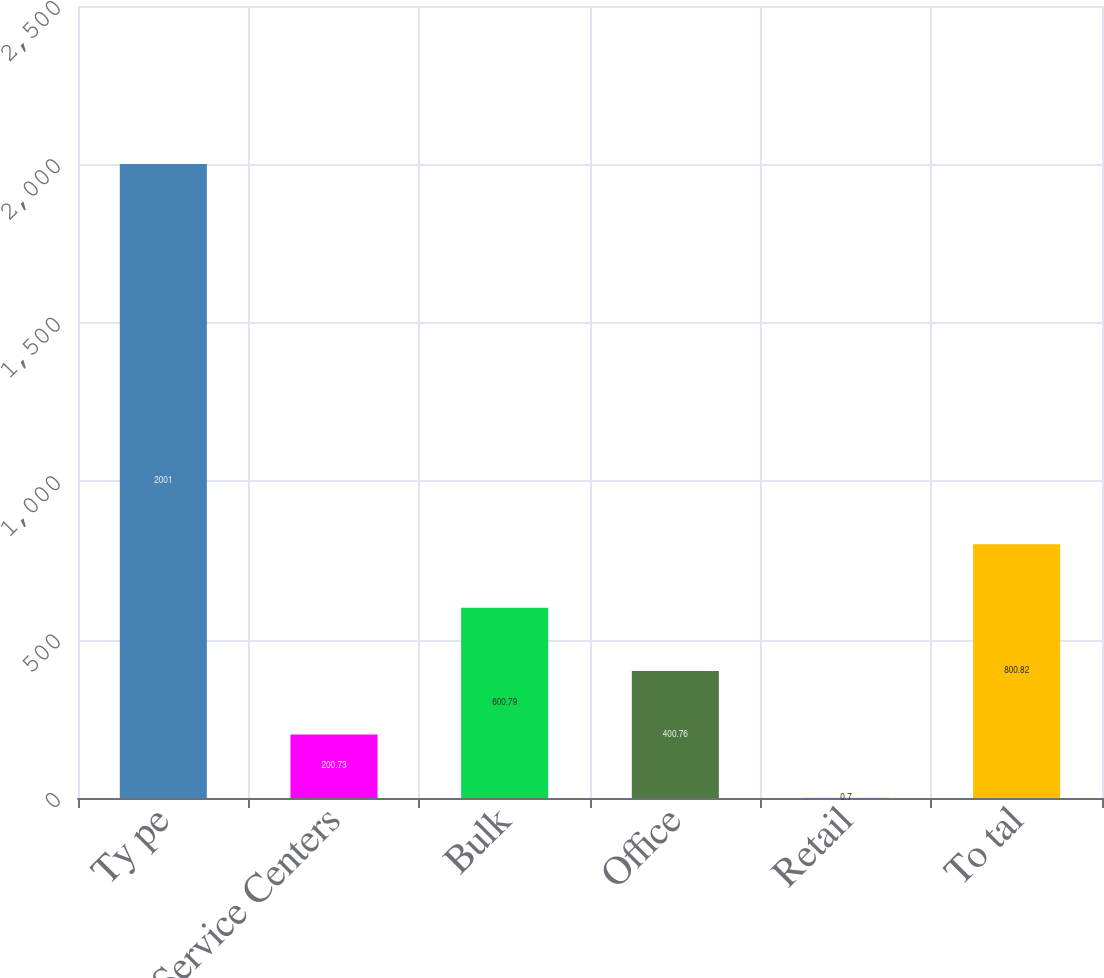<chart> <loc_0><loc_0><loc_500><loc_500><bar_chart><fcel>Ty pe<fcel>Service Centers<fcel>Bulk<fcel>Office<fcel>Retail<fcel>To tal<nl><fcel>2001<fcel>200.73<fcel>600.79<fcel>400.76<fcel>0.7<fcel>800.82<nl></chart> 